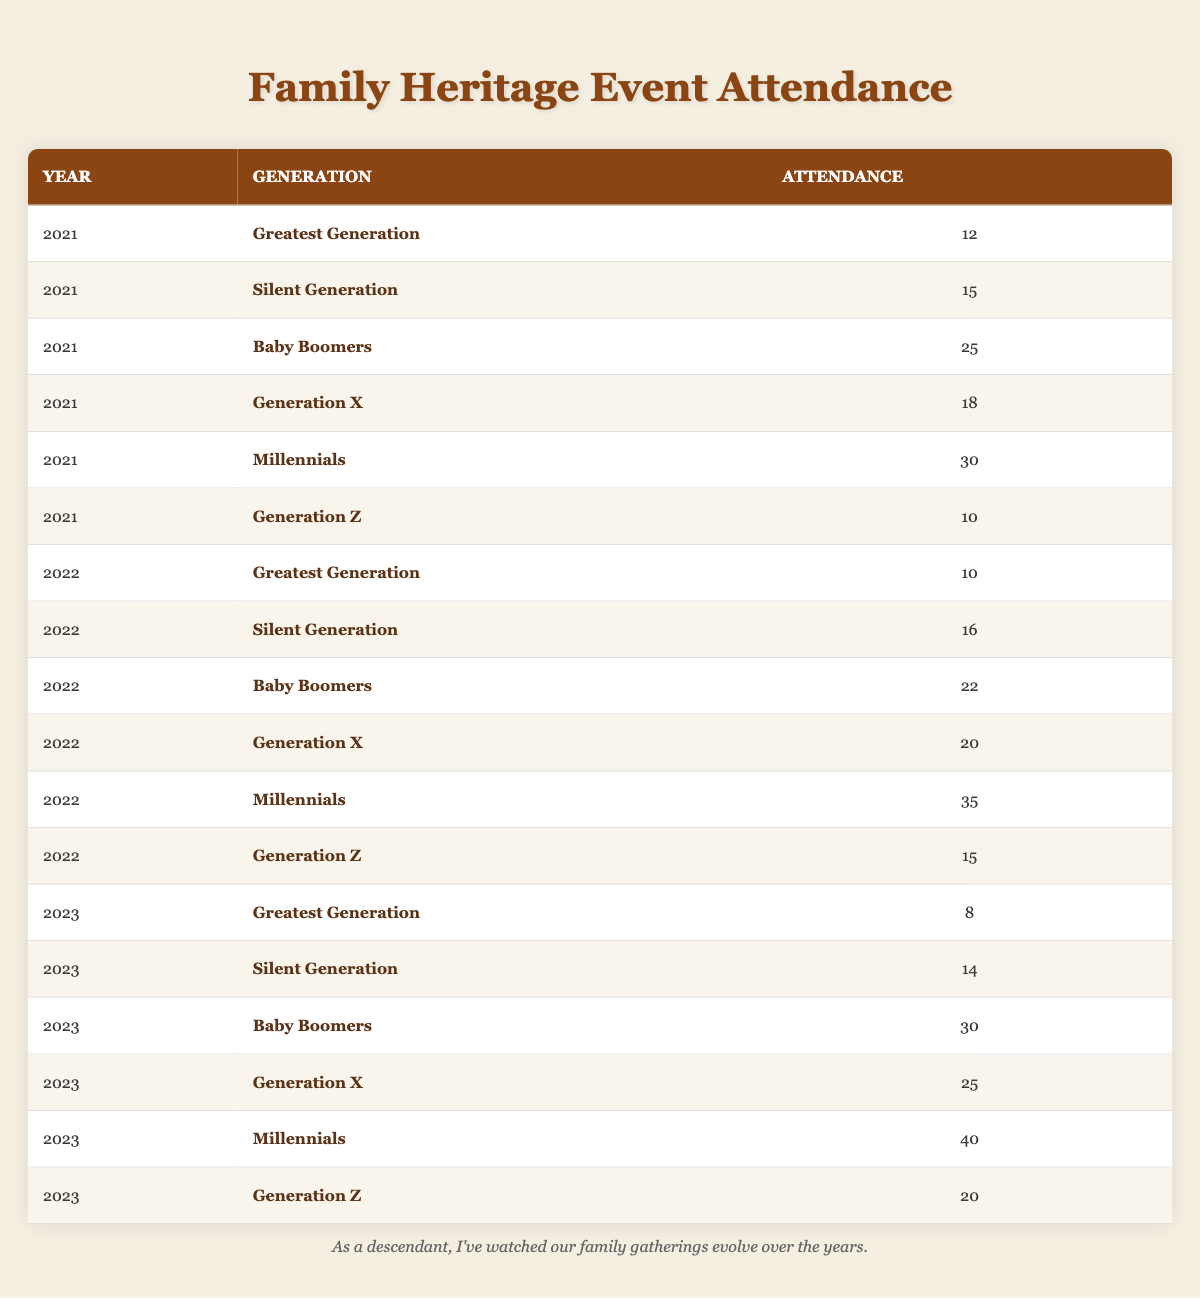What was the attendance of Millennials in 2021? In the table for 2021, the row for Millennials shows an attendance of 30.
Answer: 30 What generation had the highest attendance in 2022? By examining the attendance numbers for each generation in 2022, the Millennials had the highest attendance with 35 people.
Answer: Millennials How many more Baby Boomers attended in 2023 compared to 2021? The attendance for Baby Boomers in 2023 is 30, while in 2021 it was 25. Calculating the difference: 30 - 25 = 5, so 5 more Baby Boomers attended in 2023.
Answer: 5 Did the attendance of the Greatest Generation decrease from 2021 to 2023? The attendance for the Greatest Generation in 2021 was 12, and in 2023 it was 8. Since 8 is less than 12, the attendance did decrease.
Answer: Yes What is the average attendance for Generation X from 2021 to 2023? The attendance for Generation X over the three years is 18 (2021) + 20 (2022) + 25 (2023) = 63. To find the average, divide by the number of years: 63 / 3 = 21.
Answer: 21 Which generation had an attendance of 15 in 2022? Looking at the table, the Silent Generation had an attendance of 16 in 2022 but no generation had an attendance of exactly 15 in that year. Thus, none had 15.
Answer: None In which year did Generation Z have the lowest attendance? For Generation Z, the attendance was 10 in 2021, 15 in 2022, and 20 in 2023. The lowest attendance for Generation Z is 10 in 2021.
Answer: 2021 What was the total attendance for the Silent Generation from 2021 to 2023? The attendance for the Silent Generation over the three years is 15 (2021) + 16 (2022) + 14 (2023) = 45. Therefore, the total attendance is 45.
Answer: 45 What percentage of the total attendance in 2023 was represented by Millennials? The total attendance in 2023 was 8 (Greatest Generation) + 14 (Silent Generation) + 30 (Baby Boomers) + 25 (Generation X) + 40 (Millennials) + 20 (Generation Z) = 137. The percentage attributed to Millennials: (40 / 137) * 100 ≈ 29.24%. Thus, approximately 29.24% of the total attendance in 2023 was Millennials.
Answer: 29.24% 